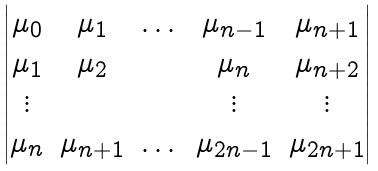Convert formula to latex. <formula><loc_0><loc_0><loc_500><loc_500>\begin{vmatrix} \mu _ { 0 } & \mu _ { 1 } & \dots & \mu _ { n - 1 } & \mu _ { n + 1 } \\ \mu _ { 1 } & \mu _ { 2 } & & \mu _ { n } & \mu _ { n + 2 } \\ \vdots & & & \vdots & \vdots \\ \mu _ { n } & \mu _ { n + 1 } & \dots & \mu _ { 2 n - 1 } & \mu _ { 2 n + 1 } \end{vmatrix}</formula> 